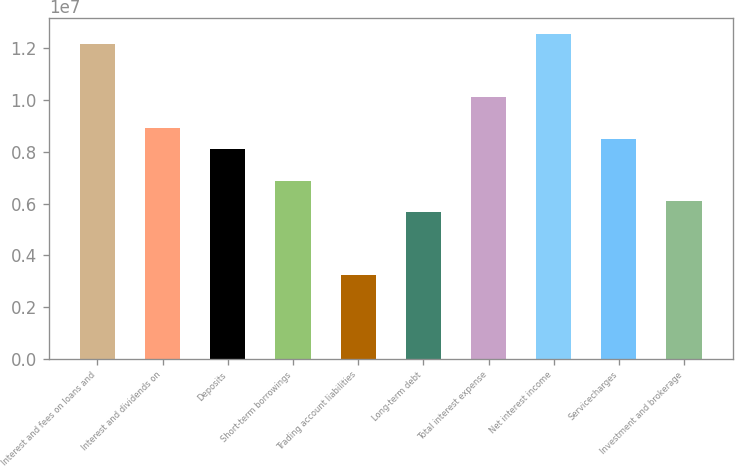Convert chart. <chart><loc_0><loc_0><loc_500><loc_500><bar_chart><fcel>Interest and fees on loans and<fcel>Interest and dividends on<fcel>Deposits<fcel>Short-term borrowings<fcel>Trading account liabilities<fcel>Long-term debt<fcel>Total interest expense<fcel>Net interest income<fcel>Servicecharges<fcel>Investment and brokerage<nl><fcel>1.21569e+07<fcel>8.91507e+06<fcel>8.10461e+06<fcel>6.88892e+06<fcel>3.24184e+06<fcel>5.67323e+06<fcel>1.01308e+07<fcel>1.25621e+07<fcel>8.50984e+06<fcel>6.07846e+06<nl></chart> 